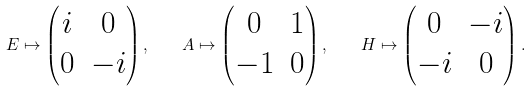<formula> <loc_0><loc_0><loc_500><loc_500>E \mapsto \begin{pmatrix} i & 0 \\ 0 & - i \end{pmatrix} , \quad A \mapsto \begin{pmatrix} 0 & 1 \\ - 1 & 0 \end{pmatrix} , \quad H \mapsto \begin{pmatrix} 0 & - i \\ - i & 0 \end{pmatrix} .</formula> 